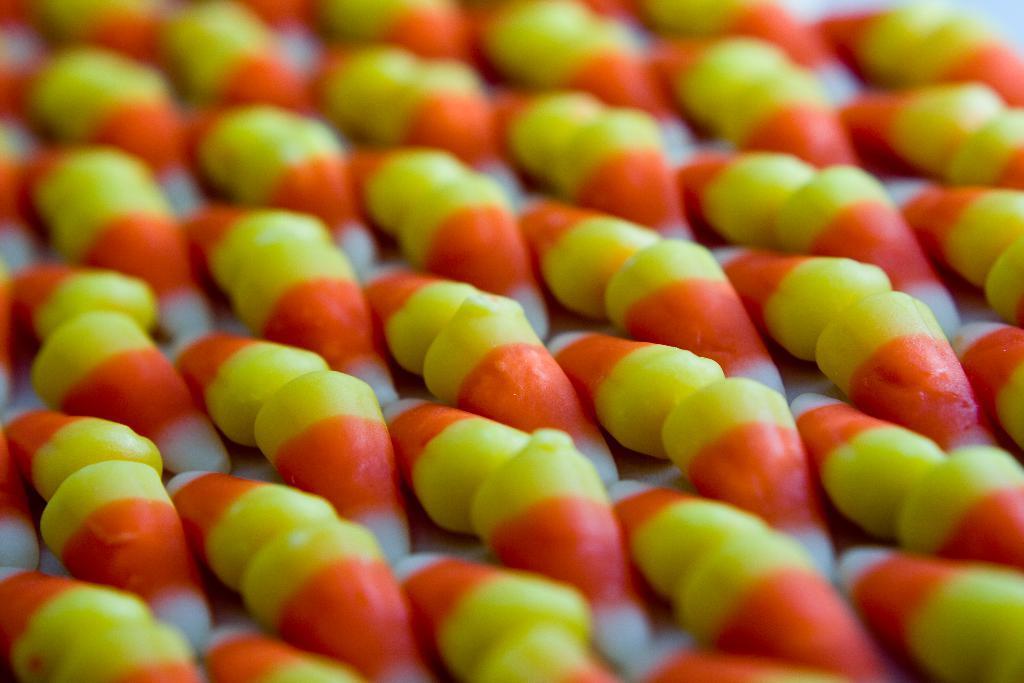How would you summarize this image in a sentence or two? In this image we can see colorful candies. 